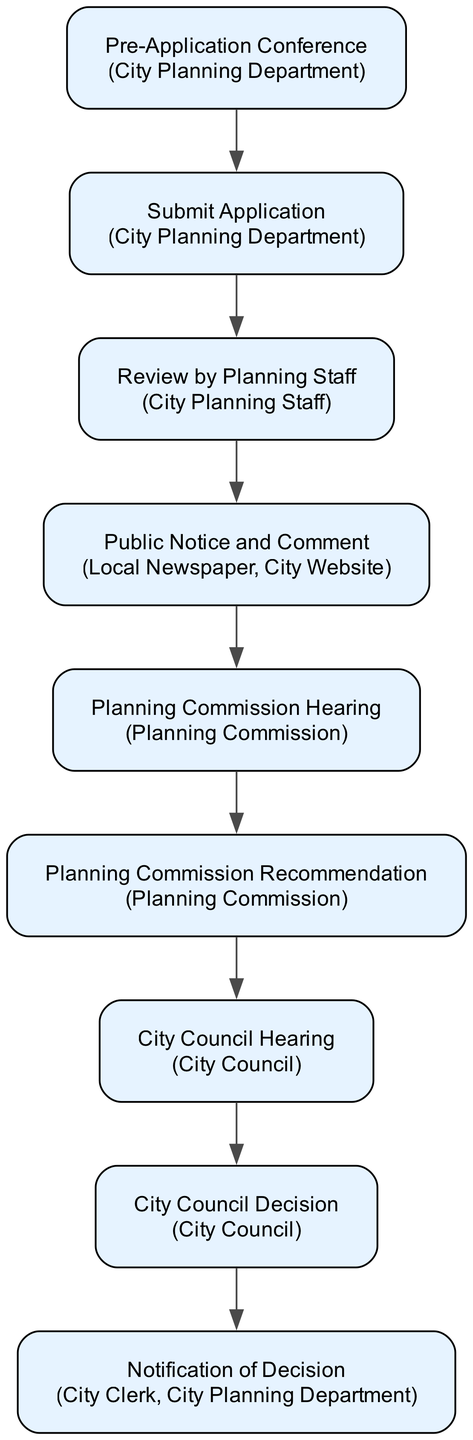What is the first step in the zoning map amendment application process? The first step is the "Pre-Application Conference" with the city's planning department to discuss the proposed zoning map amendment.
Answer: Pre-Application Conference Which entity is involved in the "Submit Application" step? The entity involved in the "Submit Application" step is the "City Planning Department," as they are responsible for receiving the application and required documents.
Answer: City Planning Department How many nodes are there in the flow chart? The flow chart contains a total of 9 nodes that represent the different steps in the zoning map amendment application process.
Answer: 9 What comes after "Public Notice and Comment"? After "Public Notice and Comment," the next step is "Planning Commission Hearing," where the public can attend a hearing to review the application and comments.
Answer: Planning Commission Hearing What is the final decision-making body in the process? The final decision-making body in the process is the "City Council," which will vote to approve, deny, or send the application back for further review.
Answer: City Council Which step involves notifying the public of the proposed amendment? The step that involves notifying the public of the proposed amendment is the "Public Notice and Comment," where notifications are made to the local newspaper and city website.
Answer: Public Notice and Comment What leap occurs after the "Planning Commission Recommendation"? After the "Planning Commission Recommendation," the application moves to the "City Council Hearing," where the council considers the recommendation and public feedback.
Answer: City Council Hearing How does the "City Council Decision" inform stakeholders? The "City Council Decision" informs stakeholders through the "Notification of Decision" step, which communicates the decision made by the council to the applicant and the public.
Answer: Notification of Decision Which step directly involves public input? The step that directly involves public input is the "Public Notice and Comment," as it allows for comments from the public regarding the proposed amendment.
Answer: Public Notice and Comment 